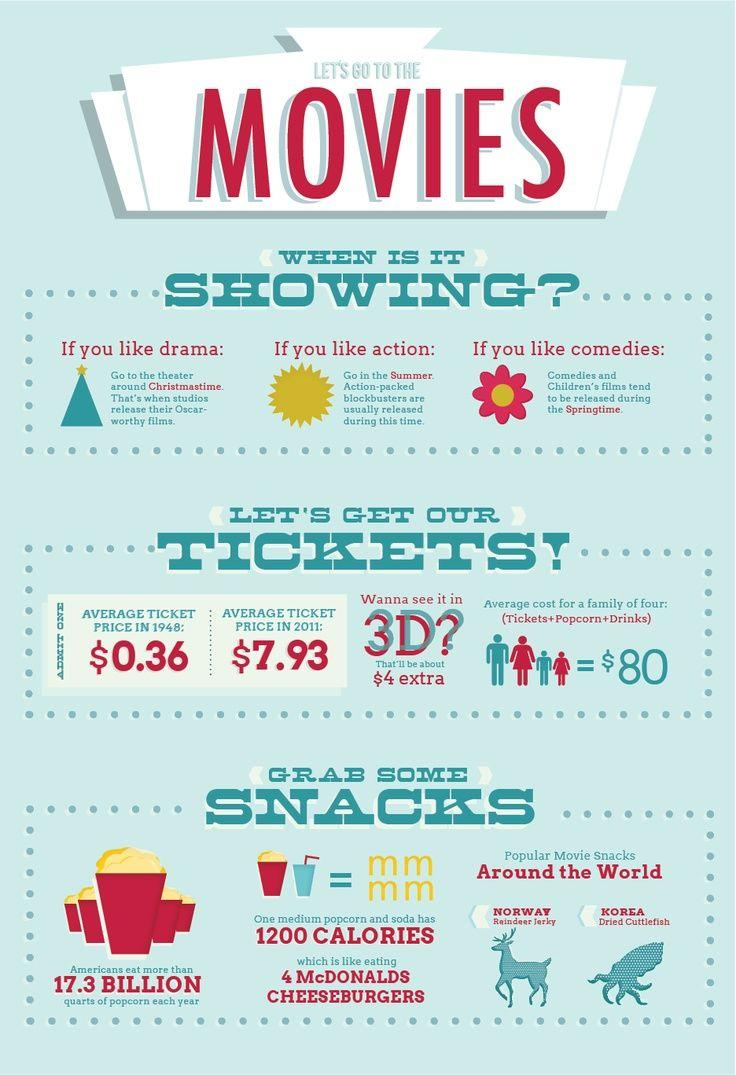Identify some key points in this picture. In Korea, dried cuttlefish is a popular movie snack. Oscar-worthy films are typically released during Christmastime. In the United States, the average cost for a family of four to eat out for a casual meal ranges from $80 to $120. The best time for action is summer. In the springtime, comedies are commonly released. 